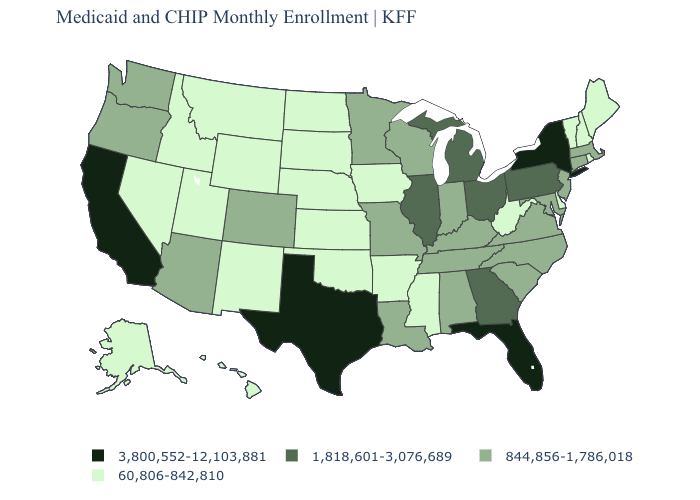Name the states that have a value in the range 3,800,552-12,103,881?
Keep it brief. California, Florida, New York, Texas. Name the states that have a value in the range 1,818,601-3,076,689?
Answer briefly. Georgia, Illinois, Michigan, Ohio, Pennsylvania. What is the value of Arkansas?
Write a very short answer. 60,806-842,810. What is the lowest value in the USA?
Answer briefly. 60,806-842,810. How many symbols are there in the legend?
Give a very brief answer. 4. Which states hav the highest value in the West?
Answer briefly. California. What is the value of Illinois?
Be succinct. 1,818,601-3,076,689. Among the states that border South Dakota , which have the lowest value?
Concise answer only. Iowa, Montana, Nebraska, North Dakota, Wyoming. Does Massachusetts have the lowest value in the Northeast?
Quick response, please. No. Name the states that have a value in the range 1,818,601-3,076,689?
Quick response, please. Georgia, Illinois, Michigan, Ohio, Pennsylvania. What is the value of Virginia?
Concise answer only. 844,856-1,786,018. Among the states that border Washington , does Oregon have the lowest value?
Give a very brief answer. No. What is the value of Iowa?
Keep it brief. 60,806-842,810. What is the value of Arizona?
Write a very short answer. 844,856-1,786,018. Which states have the highest value in the USA?
Concise answer only. California, Florida, New York, Texas. 